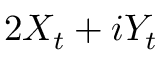<formula> <loc_0><loc_0><loc_500><loc_500>2 X _ { t } + i Y _ { t }</formula> 